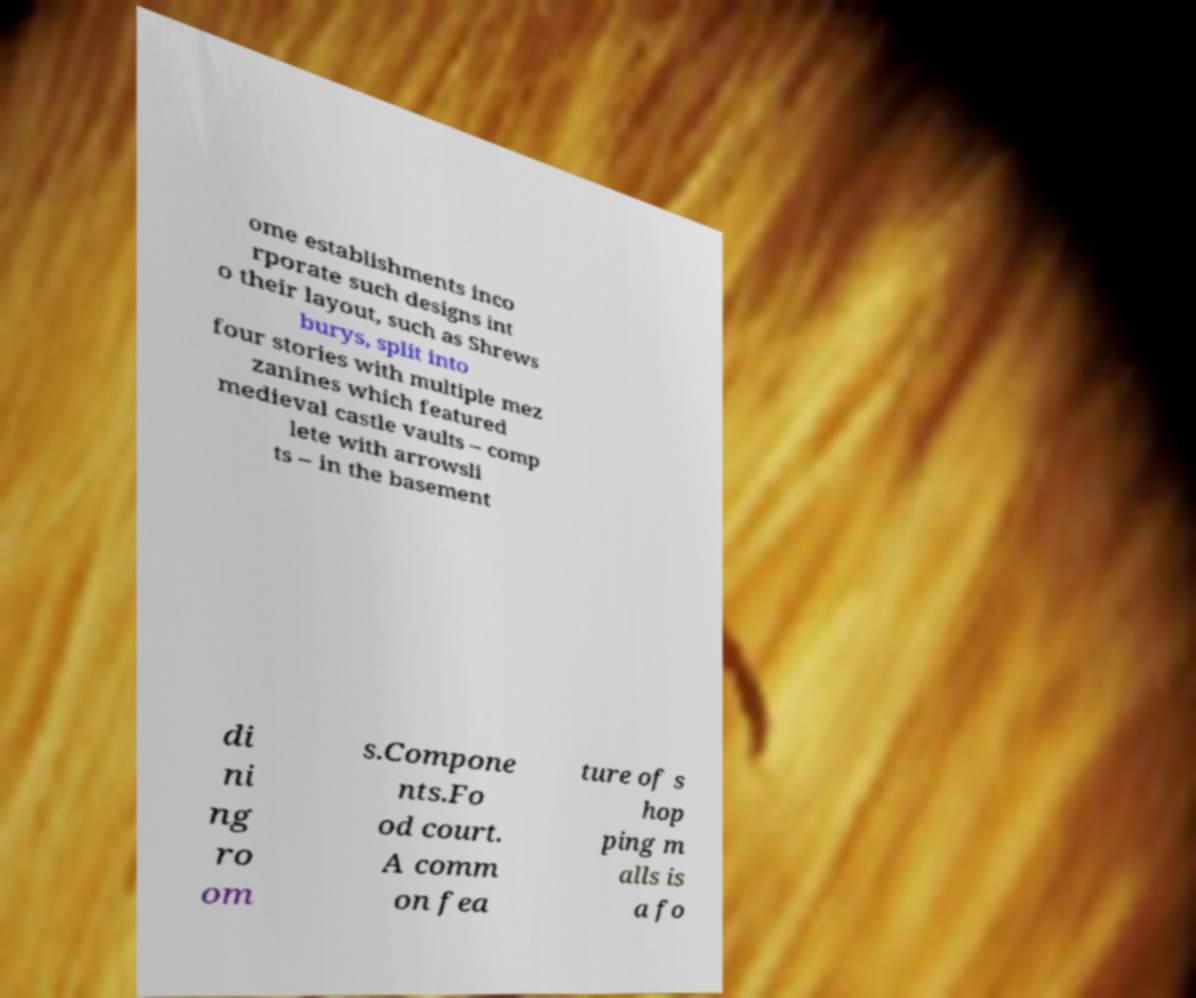For documentation purposes, I need the text within this image transcribed. Could you provide that? ome establishments inco rporate such designs int o their layout, such as Shrews burys, split into four stories with multiple mez zanines which featured medieval castle vaults – comp lete with arrowsli ts – in the basement di ni ng ro om s.Compone nts.Fo od court. A comm on fea ture of s hop ping m alls is a fo 